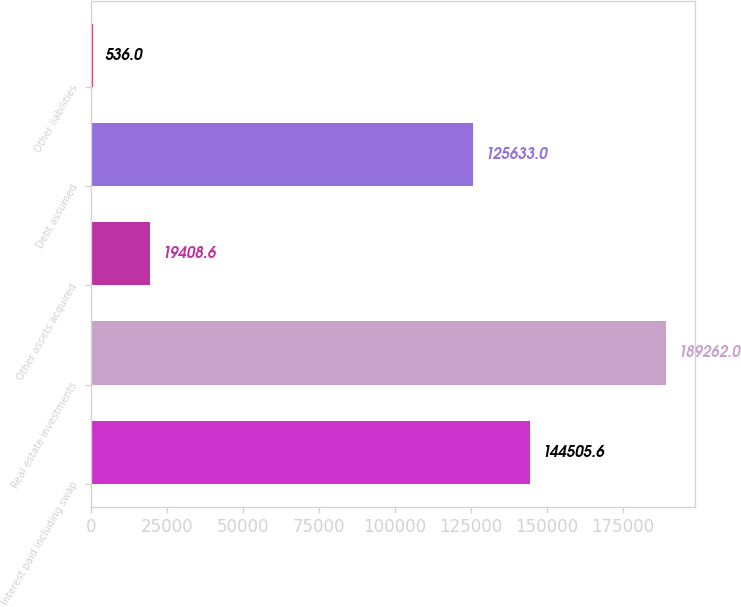Convert chart to OTSL. <chart><loc_0><loc_0><loc_500><loc_500><bar_chart><fcel>Interest paid including swap<fcel>Real estate investments<fcel>Other assets acquired<fcel>Debt assumed<fcel>Other liabilities<nl><fcel>144506<fcel>189262<fcel>19408.6<fcel>125633<fcel>536<nl></chart> 